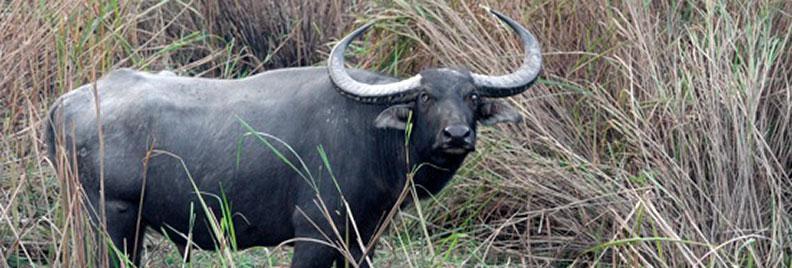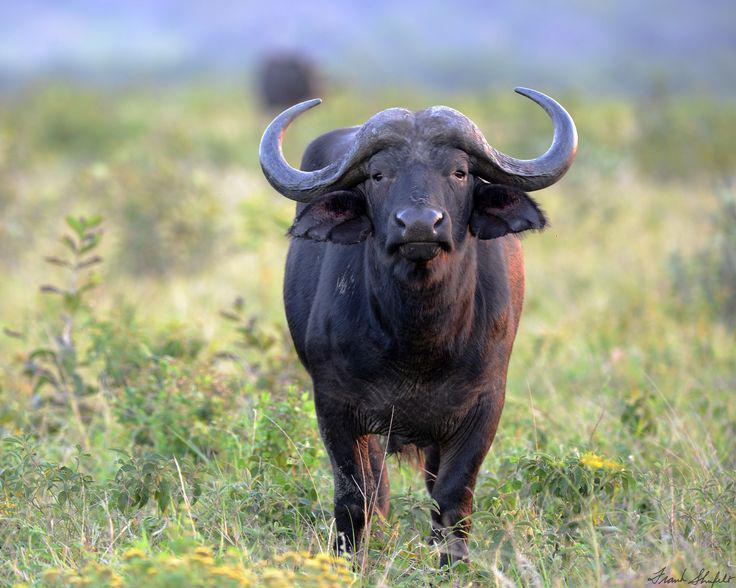The first image is the image on the left, the second image is the image on the right. Assess this claim about the two images: "There are 2 wild cattle.". Correct or not? Answer yes or no. Yes. 